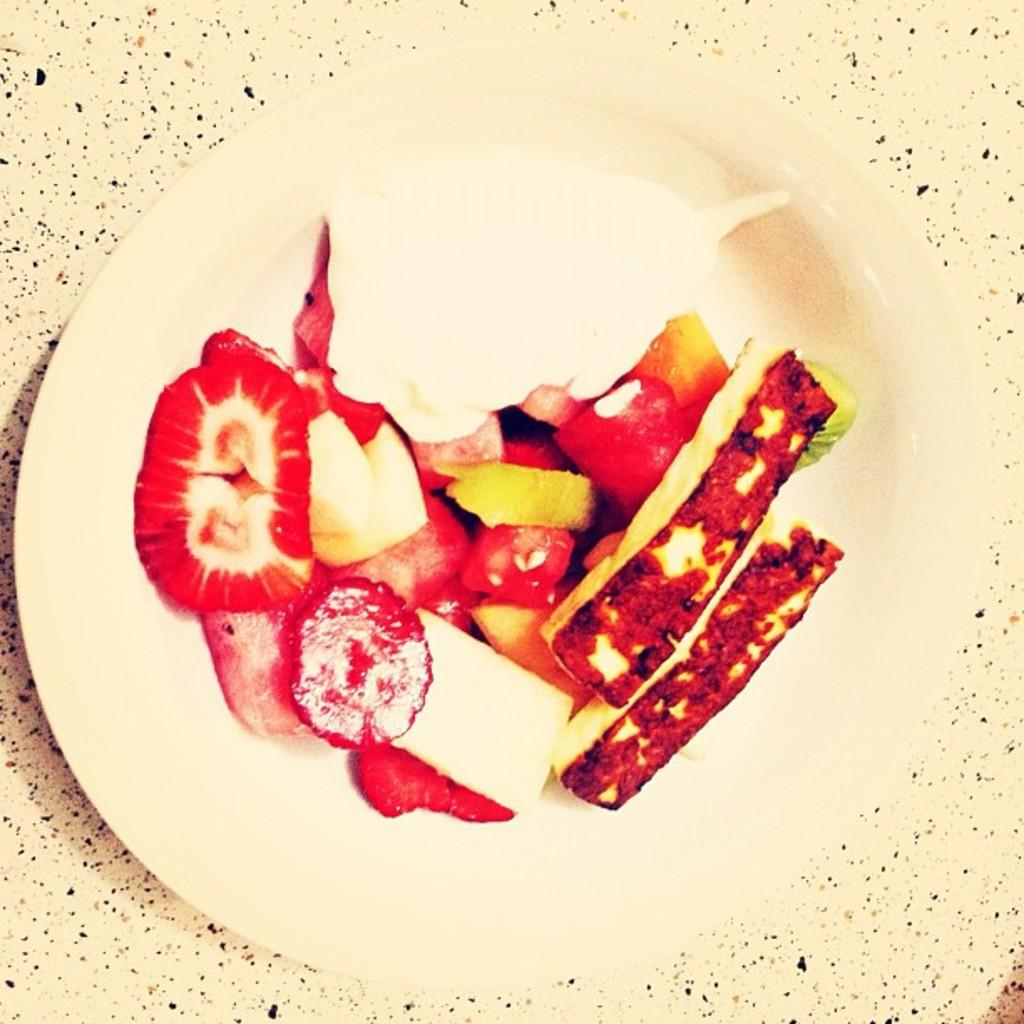What object is present in the image that typically holds food? There is a plate in the image. What is on the plate in the image? The plate contains food. Who is the health expert managing the food on the plate in the image? There is no health expert or manager present in the image; it only shows a plate with food. 